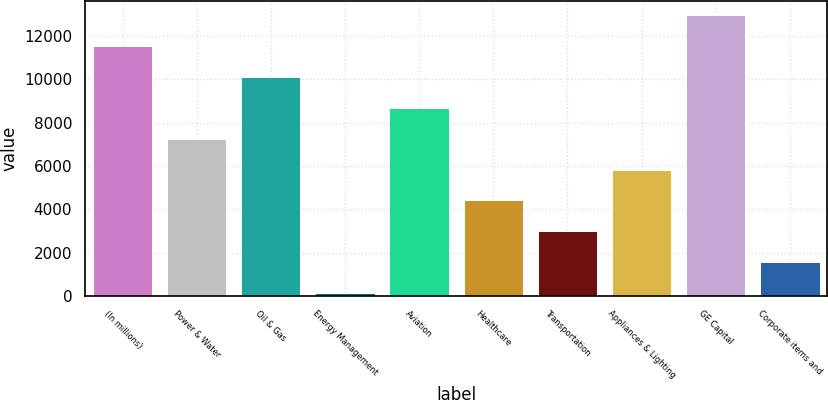Convert chart to OTSL. <chart><loc_0><loc_0><loc_500><loc_500><bar_chart><fcel>(In millions)<fcel>Power & Water<fcel>Oil & Gas<fcel>Energy Management<fcel>Aviation<fcel>Healthcare<fcel>Transportation<fcel>Appliances & Lighting<fcel>GE Capital<fcel>Corporate items and<nl><fcel>11538.6<fcel>7263<fcel>10113.4<fcel>137<fcel>8688.2<fcel>4412.6<fcel>2987.4<fcel>5837.8<fcel>12963.8<fcel>1562.2<nl></chart> 